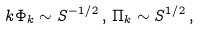<formula> <loc_0><loc_0><loc_500><loc_500>k \Phi _ { k } \sim S ^ { - 1 / 2 } \, , \, \Pi _ { k } \sim S ^ { 1 / 2 } \, ,</formula> 